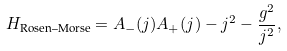<formula> <loc_0><loc_0><loc_500><loc_500>H _ { \text {Rosen--Morse} } = A _ { - } ( j ) A _ { + } ( j ) - j ^ { 2 } - \frac { g ^ { 2 } } { j ^ { 2 } } ,</formula> 